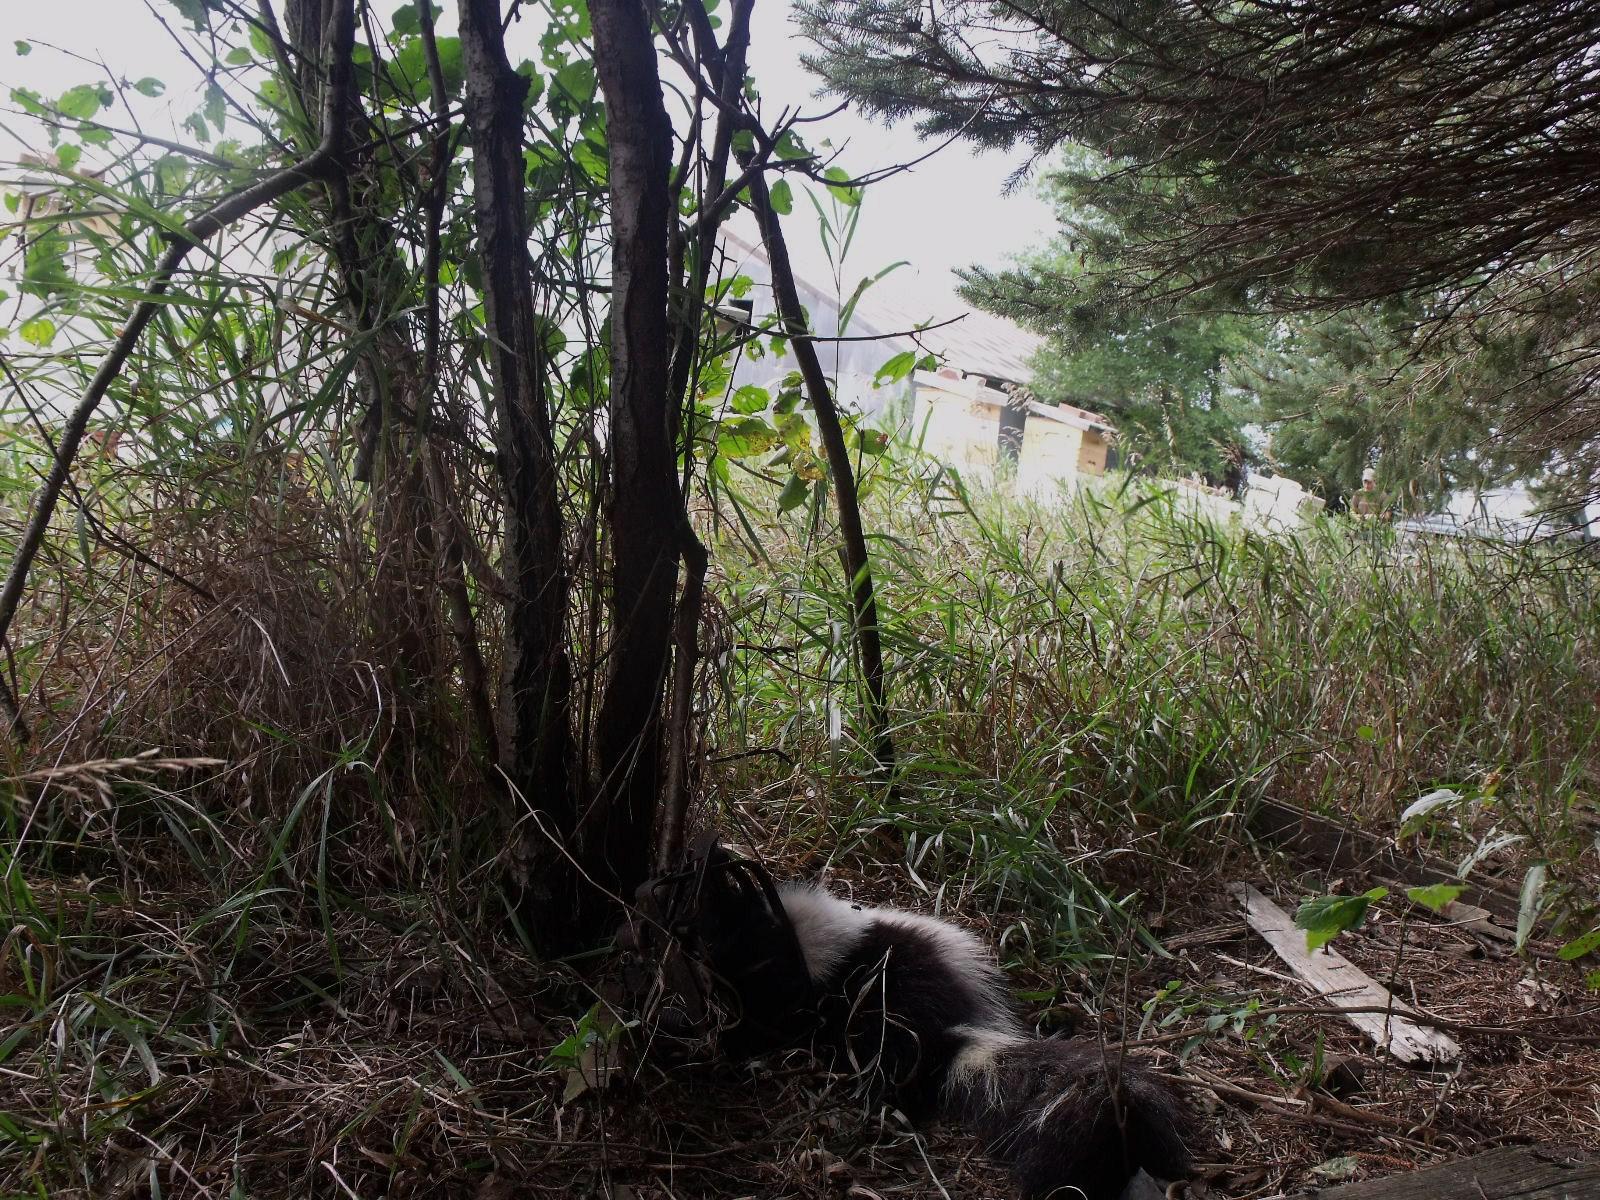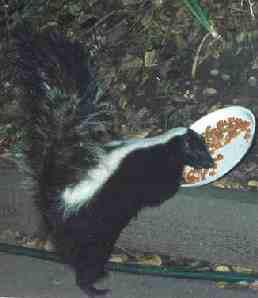The first image is the image on the left, the second image is the image on the right. Given the left and right images, does the statement "In at least one image there is a black and white skunk in the grass with its body facing left." hold true? Answer yes or no. Yes. The first image is the image on the left, the second image is the image on the right. Considering the images on both sides, is "The skunk on the left is standing still and looking forward, and the skunk on the right is trotting in a horizontal path." valid? Answer yes or no. No. 